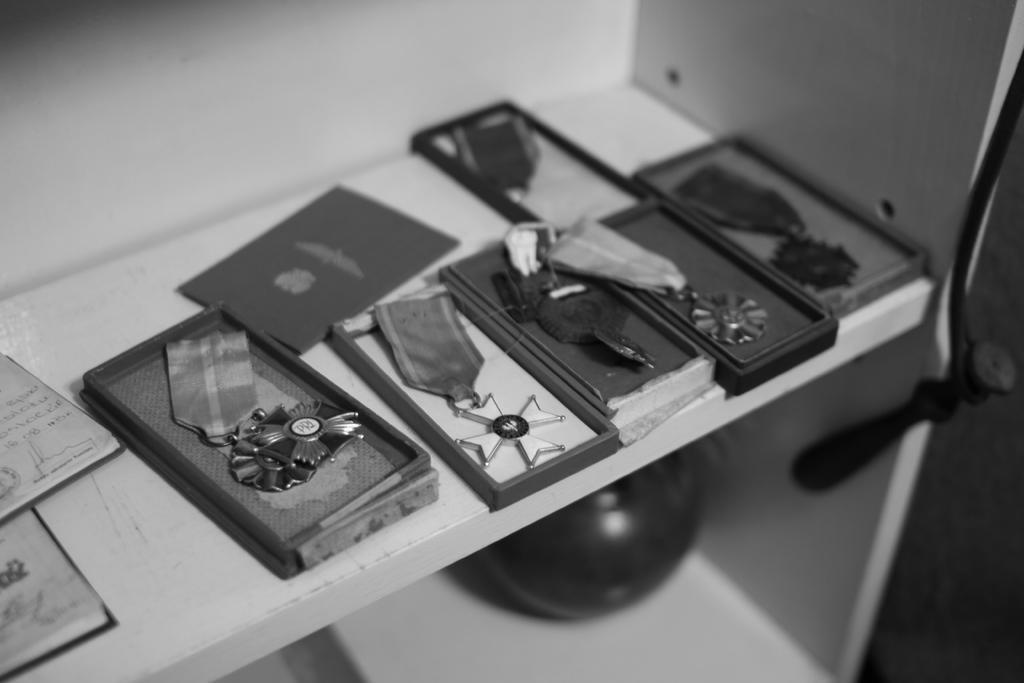In one or two sentences, can you explain what this image depicts? In this picture we can observe different types of badges. There are six badges placed in the six boxes in the shelf. This is a black and white image. 